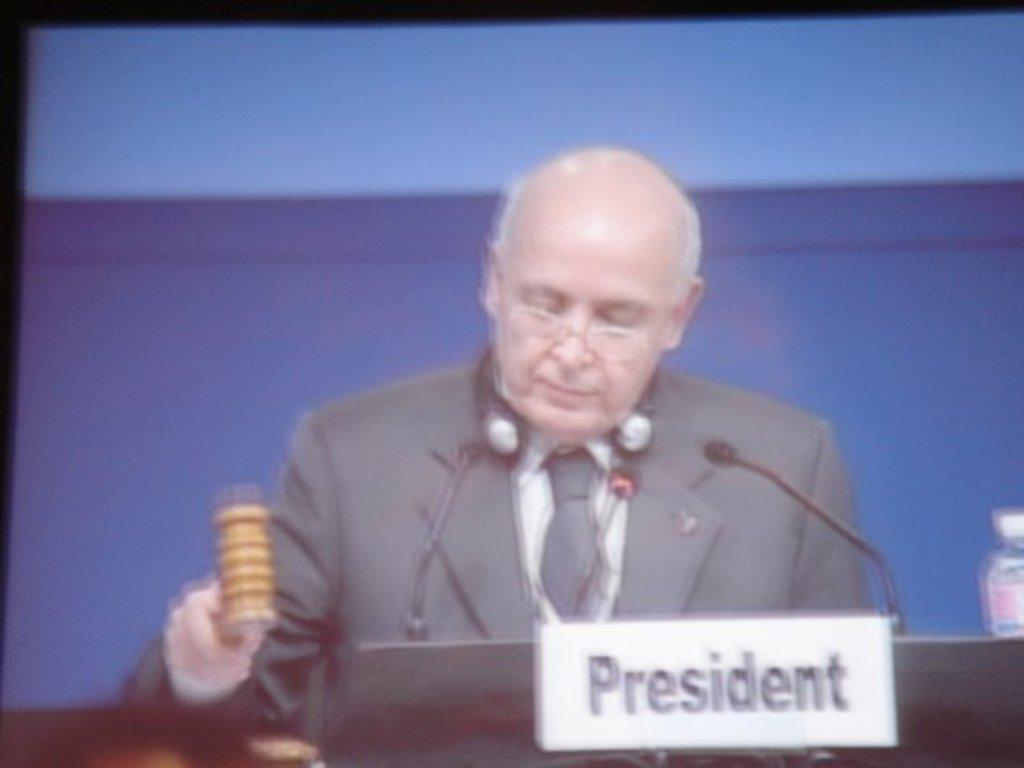What is the person in the image doing? The person is standing in front of a podium. What is attached to the podium? A mic is attached to the podium. What is the person wearing? The person is wearing a formal suit. What object is the person holding in their hand? The person is holding a hammer in their hand. What type of summer look is the person wearing in the image? The person is wearing a formal suit, which is not a summer look. Additionally, there is no mention of summer or any season in the provided facts. 